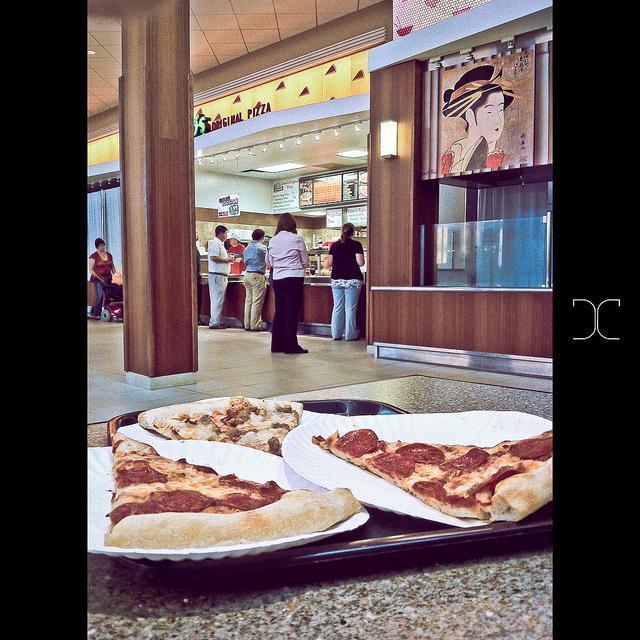Where is this taking place?
Indicate the correct choice and explain in the format: 'Answer: answer
Rationale: rationale.'
Options: Mcdonald's, street vending, kfc, food court. Answer: food court.
Rationale: There are other businesses next to it 